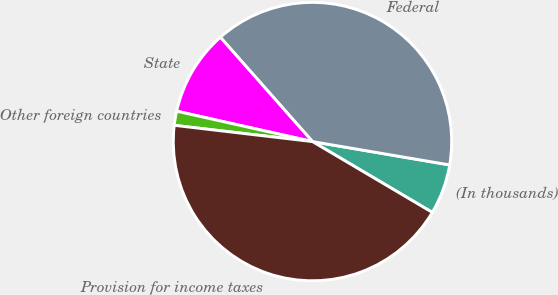<chart> <loc_0><loc_0><loc_500><loc_500><pie_chart><fcel>(In thousands)<fcel>Federal<fcel>State<fcel>Other foreign countries<fcel>Provision for income taxes<nl><fcel>5.81%<fcel>39.2%<fcel>9.98%<fcel>1.64%<fcel>43.37%<nl></chart> 